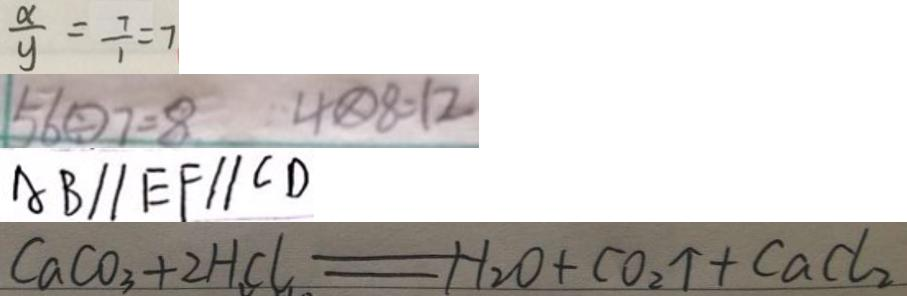Convert formula to latex. <formula><loc_0><loc_0><loc_500><loc_500>\frac { x } { y } = \frac { 7 } { 1 } = 7 
 5 6 \textcircled { \div } 7 = 8 4 \textcircled { \times } 8 = 1 2 
 A B / / E F / / C D 
 C a C O _ { 3 } + 2 H C l = H _ { 2 } O + C O _ { 2 } \uparrow + C a C l _ { 2 }</formula> 